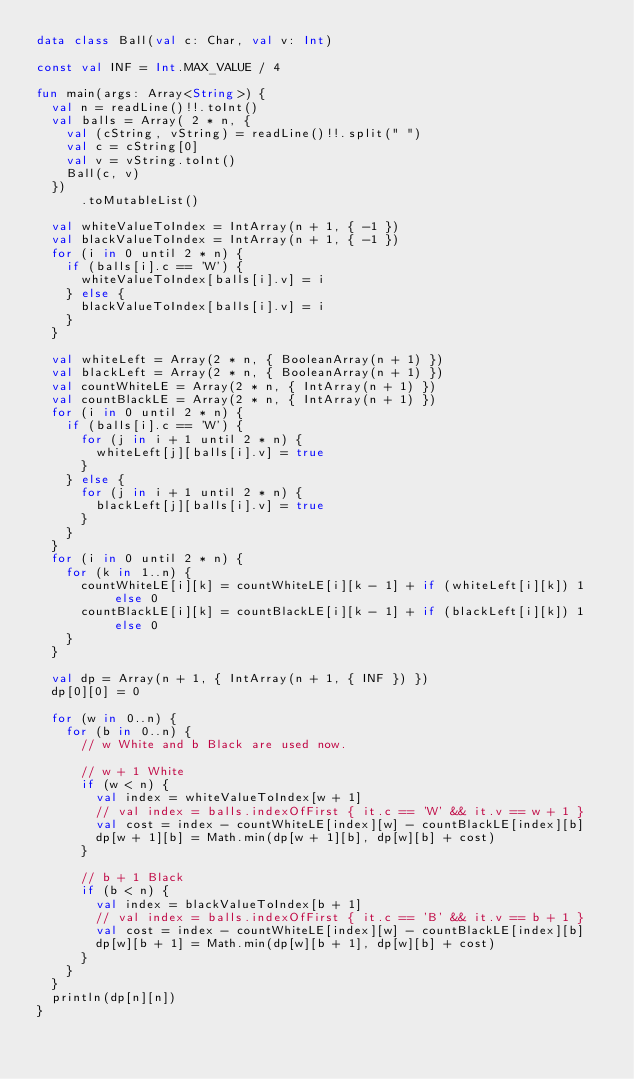Convert code to text. <code><loc_0><loc_0><loc_500><loc_500><_Kotlin_>data class Ball(val c: Char, val v: Int)

const val INF = Int.MAX_VALUE / 4

fun main(args: Array<String>) {
  val n = readLine()!!.toInt()
  val balls = Array( 2 * n, {
    val (cString, vString) = readLine()!!.split(" ")
    val c = cString[0]
    val v = vString.toInt()
    Ball(c, v)
  })
      .toMutableList()

  val whiteValueToIndex = IntArray(n + 1, { -1 })
  val blackValueToIndex = IntArray(n + 1, { -1 })
  for (i in 0 until 2 * n) {
    if (balls[i].c == 'W') {
      whiteValueToIndex[balls[i].v] = i
    } else {
      blackValueToIndex[balls[i].v] = i
    }
  }

  val whiteLeft = Array(2 * n, { BooleanArray(n + 1) })
  val blackLeft = Array(2 * n, { BooleanArray(n + 1) })
  val countWhiteLE = Array(2 * n, { IntArray(n + 1) })
  val countBlackLE = Array(2 * n, { IntArray(n + 1) })
  for (i in 0 until 2 * n) {
    if (balls[i].c == 'W') {
      for (j in i + 1 until 2 * n) {
        whiteLeft[j][balls[i].v] = true
      }
    } else {
      for (j in i + 1 until 2 * n) {
        blackLeft[j][balls[i].v] = true
      }
    }
  }
  for (i in 0 until 2 * n) {
    for (k in 1..n) {
      countWhiteLE[i][k] = countWhiteLE[i][k - 1] + if (whiteLeft[i][k]) 1 else 0
      countBlackLE[i][k] = countBlackLE[i][k - 1] + if (blackLeft[i][k]) 1 else 0
    }
  }

  val dp = Array(n + 1, { IntArray(n + 1, { INF }) })
  dp[0][0] = 0

  for (w in 0..n) {
    for (b in 0..n) {
      // w White and b Black are used now.

      // w + 1 White
      if (w < n) {
        val index = whiteValueToIndex[w + 1]
        // val index = balls.indexOfFirst { it.c == 'W' && it.v == w + 1 }
        val cost = index - countWhiteLE[index][w] - countBlackLE[index][b]
        dp[w + 1][b] = Math.min(dp[w + 1][b], dp[w][b] + cost)
      }

      // b + 1 Black
      if (b < n) {
        val index = blackValueToIndex[b + 1]
        // val index = balls.indexOfFirst { it.c == 'B' && it.v == b + 1 }
        val cost = index - countWhiteLE[index][w] - countBlackLE[index][b]
        dp[w][b + 1] = Math.min(dp[w][b + 1], dp[w][b] + cost)
      }
    }
  }
  println(dp[n][n])
}
</code> 